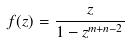Convert formula to latex. <formula><loc_0><loc_0><loc_500><loc_500>f ( z ) = \frac { z } { 1 - z ^ { m + n - 2 } }</formula> 